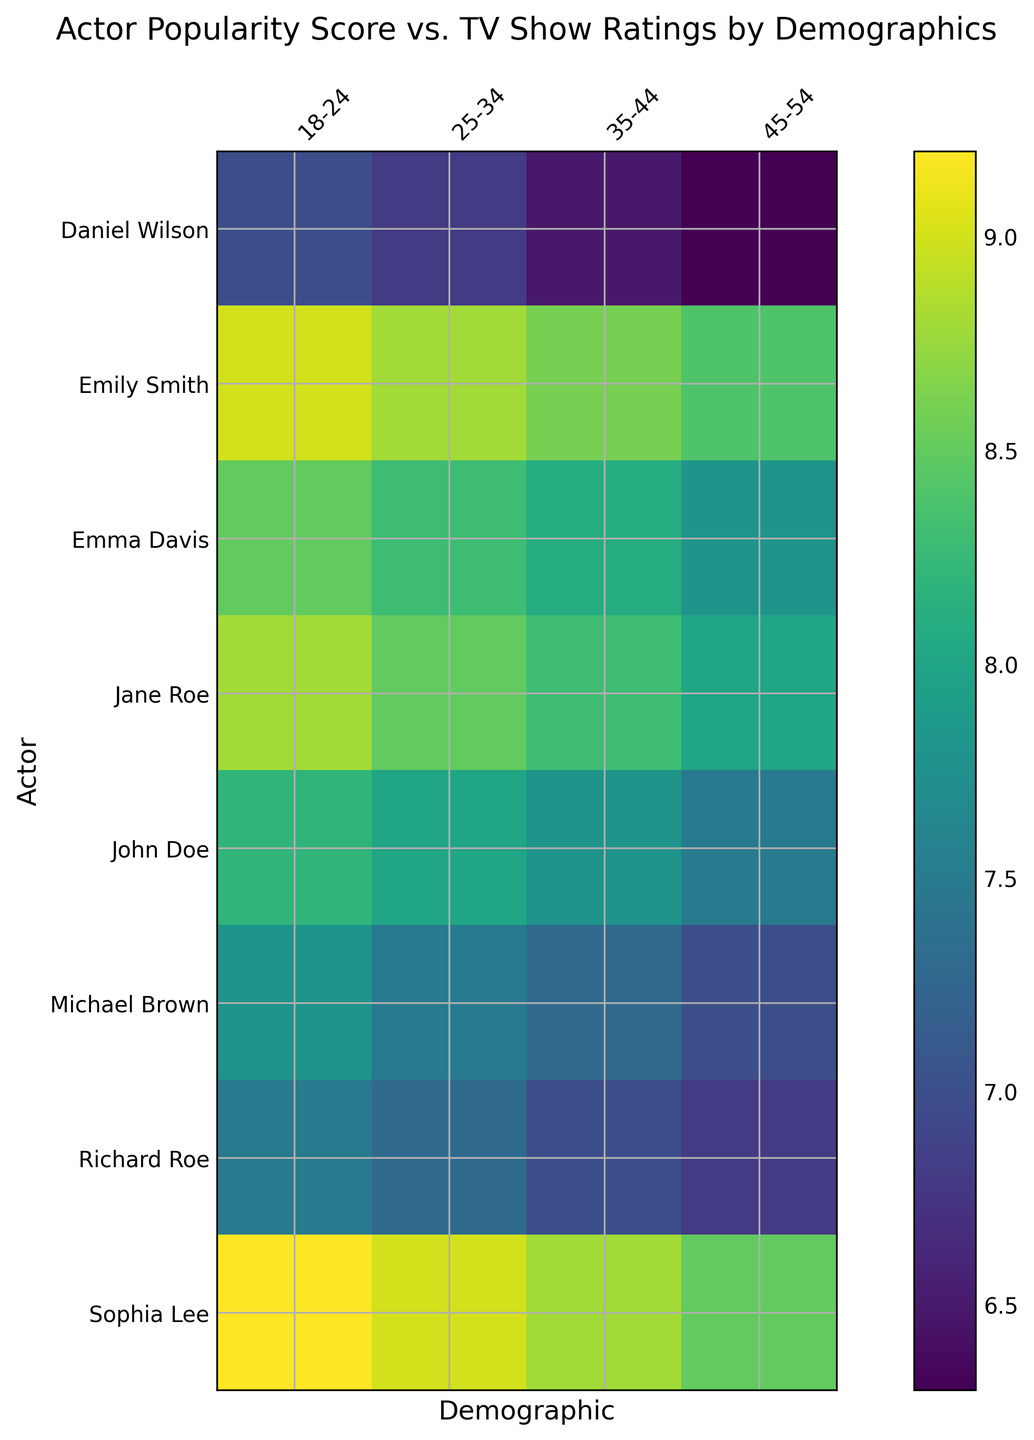Which actor has the highest TV show rating for the 18-24 demographic? Locate the column for the 18-24 demographic and find the row with the darkest color, indicating the highest rating.
Answer: Sophia Lee How does John Doe's popularity score relate to his TV show rating for the 45-54 demographic? Identify John Doe's row and find the column for the 45-54 demographic. Note the values: a popularity score of 75 correlates with a show rating of 7.5.
Answer: 75 popularity, 7.5 rating Which demographic gives Jane Roe the highest TV show rating? Observe Jane Roe's row and find the brightest color, indicating the highest rating among the demographics.
Answer: 18-24 What is the average TV show rating for Richard Roe across all demographics? Sum the ratings for Richard Roe across all demographics (7.5 + 7.3 + 7.0 + 6.8) and divide by 4. (7.5 + 7.3 + 7.0 + 6.8) / 4 = 7.15
Answer: 7.15 Compare the TV show ratings of Emily Smith and Michael Brown for the 25-34 demographic. Locate the ratings for Emily Smith and Michael Brown in the 25-34 column and compare them: 8.8 for Emily Smith and 7.5 for Michael Brown.
Answer: Emily Smith Who has a higher TV show rating for the 35-44 demographic, Emma Davis or Daniel Wilson? Locate the 35-44 column and compare the ratings of Emma Davis (8.1) and Daniel Wilson (6.5).
Answer: Emma Davis By how much does Sophia Lee's TV show rating decrease from the 18-24 demographic to the 45-54 demographic? Subtract the show rating for the 45-54 demographic from the show rating for the 18-24 demographic: 9.2 - 8.5 = 0.7
Answer: 0.7 What is the difference in TV show ratings between the highest and lowest scores by any actor for the 25-34 demographic? Identify the highest (9.0 by Sophia Lee) and lowest (6.8 by Daniel Wilson) ratings in the 25-34 column and subtract: 9.0 - 6.8 = 2.2
Answer: 2.2 Visually, which actor's ratings show the least variance across demographics? Look for the row with the most uniform color shading across columns, indicating minimal variation.
Answer: John Doe What is the combined TV show rating for Michael Brown and Jane Roe in the 35-44 demographic? Locate the 35-44 column and sum the ratings of Michael Brown (7.3) and Jane Roe (8.3): 7.3 + 8.3 = 15.6
Answer: 15.6 